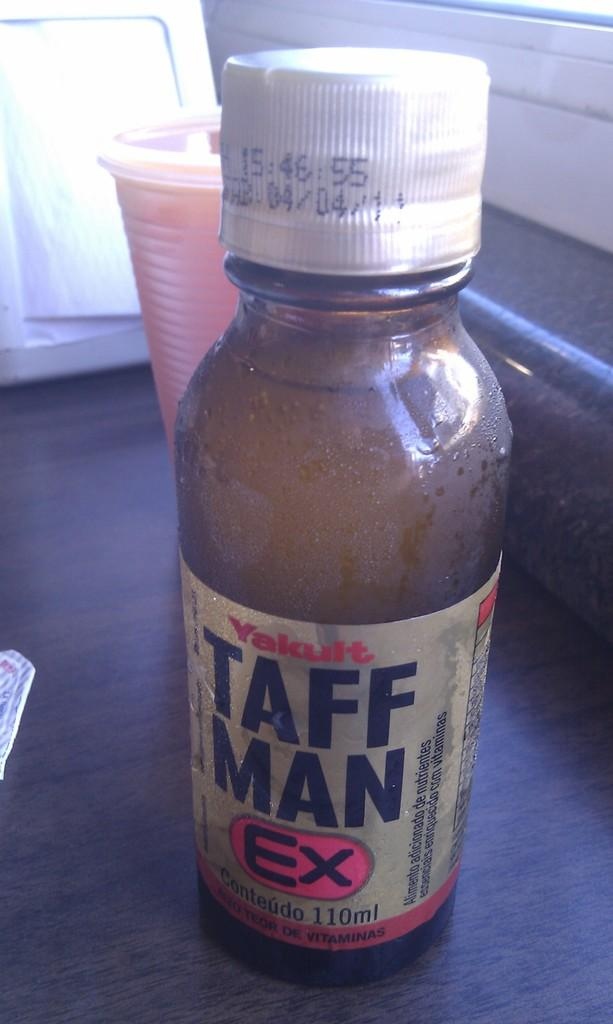What type of container is visible in the image? There is a beverage bottle in the image. What other object is present in the image that could be used for drinking? There is a glass in the image. Where are the bottle and the glass located in the image? Both the bottle and the glass are placed on a table. What language is being spoken by the people in the park in the image? There are no people or park present in the image; it only features a beverage bottle and a glass on a table. 